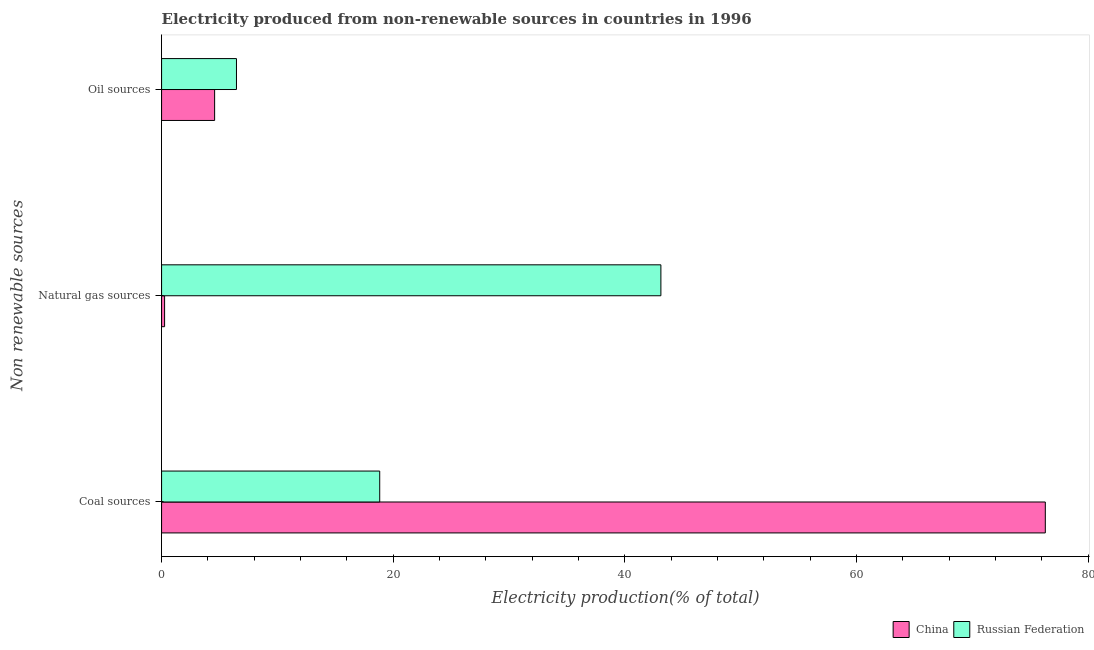Are the number of bars on each tick of the Y-axis equal?
Make the answer very short. Yes. How many bars are there on the 1st tick from the top?
Your answer should be very brief. 2. How many bars are there on the 3rd tick from the bottom?
Your response must be concise. 2. What is the label of the 2nd group of bars from the top?
Your answer should be compact. Natural gas sources. What is the percentage of electricity produced by coal in Russian Federation?
Keep it short and to the point. 18.83. Across all countries, what is the maximum percentage of electricity produced by coal?
Ensure brevity in your answer.  76.29. Across all countries, what is the minimum percentage of electricity produced by oil sources?
Your answer should be compact. 4.58. What is the total percentage of electricity produced by coal in the graph?
Your response must be concise. 95.12. What is the difference between the percentage of electricity produced by coal in China and that in Russian Federation?
Your answer should be very brief. 57.46. What is the difference between the percentage of electricity produced by coal in Russian Federation and the percentage of electricity produced by oil sources in China?
Make the answer very short. 14.25. What is the average percentage of electricity produced by oil sources per country?
Provide a short and direct response. 5.52. What is the difference between the percentage of electricity produced by natural gas and percentage of electricity produced by oil sources in China?
Give a very brief answer. -4.32. In how many countries, is the percentage of electricity produced by coal greater than 76 %?
Offer a very short reply. 1. What is the ratio of the percentage of electricity produced by oil sources in Russian Federation to that in China?
Your answer should be very brief. 1.41. What is the difference between the highest and the second highest percentage of electricity produced by oil sources?
Ensure brevity in your answer.  1.89. What is the difference between the highest and the lowest percentage of electricity produced by natural gas?
Give a very brief answer. 42.84. In how many countries, is the percentage of electricity produced by natural gas greater than the average percentage of electricity produced by natural gas taken over all countries?
Offer a very short reply. 1. What does the 2nd bar from the bottom in Coal sources represents?
Provide a succinct answer. Russian Federation. How many bars are there?
Ensure brevity in your answer.  6. Are all the bars in the graph horizontal?
Provide a short and direct response. Yes. Are the values on the major ticks of X-axis written in scientific E-notation?
Make the answer very short. No. How many legend labels are there?
Your answer should be compact. 2. How are the legend labels stacked?
Ensure brevity in your answer.  Horizontal. What is the title of the graph?
Your response must be concise. Electricity produced from non-renewable sources in countries in 1996. Does "Cayman Islands" appear as one of the legend labels in the graph?
Your answer should be compact. No. What is the label or title of the X-axis?
Provide a short and direct response. Electricity production(% of total). What is the label or title of the Y-axis?
Provide a short and direct response. Non renewable sources. What is the Electricity production(% of total) in China in Coal sources?
Provide a short and direct response. 76.29. What is the Electricity production(% of total) of Russian Federation in Coal sources?
Offer a very short reply. 18.83. What is the Electricity production(% of total) of China in Natural gas sources?
Keep it short and to the point. 0.26. What is the Electricity production(% of total) of Russian Federation in Natural gas sources?
Give a very brief answer. 43.1. What is the Electricity production(% of total) in China in Oil sources?
Offer a terse response. 4.58. What is the Electricity production(% of total) in Russian Federation in Oil sources?
Offer a terse response. 6.47. Across all Non renewable sources, what is the maximum Electricity production(% of total) in China?
Ensure brevity in your answer.  76.29. Across all Non renewable sources, what is the maximum Electricity production(% of total) in Russian Federation?
Provide a short and direct response. 43.1. Across all Non renewable sources, what is the minimum Electricity production(% of total) in China?
Ensure brevity in your answer.  0.26. Across all Non renewable sources, what is the minimum Electricity production(% of total) in Russian Federation?
Keep it short and to the point. 6.47. What is the total Electricity production(% of total) of China in the graph?
Your response must be concise. 81.13. What is the total Electricity production(% of total) of Russian Federation in the graph?
Offer a very short reply. 68.4. What is the difference between the Electricity production(% of total) of China in Coal sources and that in Natural gas sources?
Your answer should be compact. 76.03. What is the difference between the Electricity production(% of total) of Russian Federation in Coal sources and that in Natural gas sources?
Provide a short and direct response. -24.27. What is the difference between the Electricity production(% of total) of China in Coal sources and that in Oil sources?
Your answer should be compact. 71.71. What is the difference between the Electricity production(% of total) in Russian Federation in Coal sources and that in Oil sources?
Make the answer very short. 12.37. What is the difference between the Electricity production(% of total) in China in Natural gas sources and that in Oil sources?
Offer a terse response. -4.32. What is the difference between the Electricity production(% of total) in Russian Federation in Natural gas sources and that in Oil sources?
Your answer should be very brief. 36.64. What is the difference between the Electricity production(% of total) in China in Coal sources and the Electricity production(% of total) in Russian Federation in Natural gas sources?
Provide a succinct answer. 33.19. What is the difference between the Electricity production(% of total) of China in Coal sources and the Electricity production(% of total) of Russian Federation in Oil sources?
Offer a very short reply. 69.82. What is the difference between the Electricity production(% of total) of China in Natural gas sources and the Electricity production(% of total) of Russian Federation in Oil sources?
Offer a very short reply. -6.2. What is the average Electricity production(% of total) in China per Non renewable sources?
Offer a terse response. 27.04. What is the average Electricity production(% of total) in Russian Federation per Non renewable sources?
Offer a very short reply. 22.8. What is the difference between the Electricity production(% of total) of China and Electricity production(% of total) of Russian Federation in Coal sources?
Make the answer very short. 57.46. What is the difference between the Electricity production(% of total) in China and Electricity production(% of total) in Russian Federation in Natural gas sources?
Keep it short and to the point. -42.84. What is the difference between the Electricity production(% of total) of China and Electricity production(% of total) of Russian Federation in Oil sources?
Offer a very short reply. -1.89. What is the ratio of the Electricity production(% of total) of China in Coal sources to that in Natural gas sources?
Offer a terse response. 292.2. What is the ratio of the Electricity production(% of total) of Russian Federation in Coal sources to that in Natural gas sources?
Your answer should be compact. 0.44. What is the ratio of the Electricity production(% of total) of China in Coal sources to that in Oil sources?
Give a very brief answer. 16.66. What is the ratio of the Electricity production(% of total) of Russian Federation in Coal sources to that in Oil sources?
Provide a succinct answer. 2.91. What is the ratio of the Electricity production(% of total) of China in Natural gas sources to that in Oil sources?
Your response must be concise. 0.06. What is the ratio of the Electricity production(% of total) in Russian Federation in Natural gas sources to that in Oil sources?
Provide a succinct answer. 6.67. What is the difference between the highest and the second highest Electricity production(% of total) in China?
Keep it short and to the point. 71.71. What is the difference between the highest and the second highest Electricity production(% of total) in Russian Federation?
Provide a short and direct response. 24.27. What is the difference between the highest and the lowest Electricity production(% of total) of China?
Provide a short and direct response. 76.03. What is the difference between the highest and the lowest Electricity production(% of total) of Russian Federation?
Ensure brevity in your answer.  36.64. 